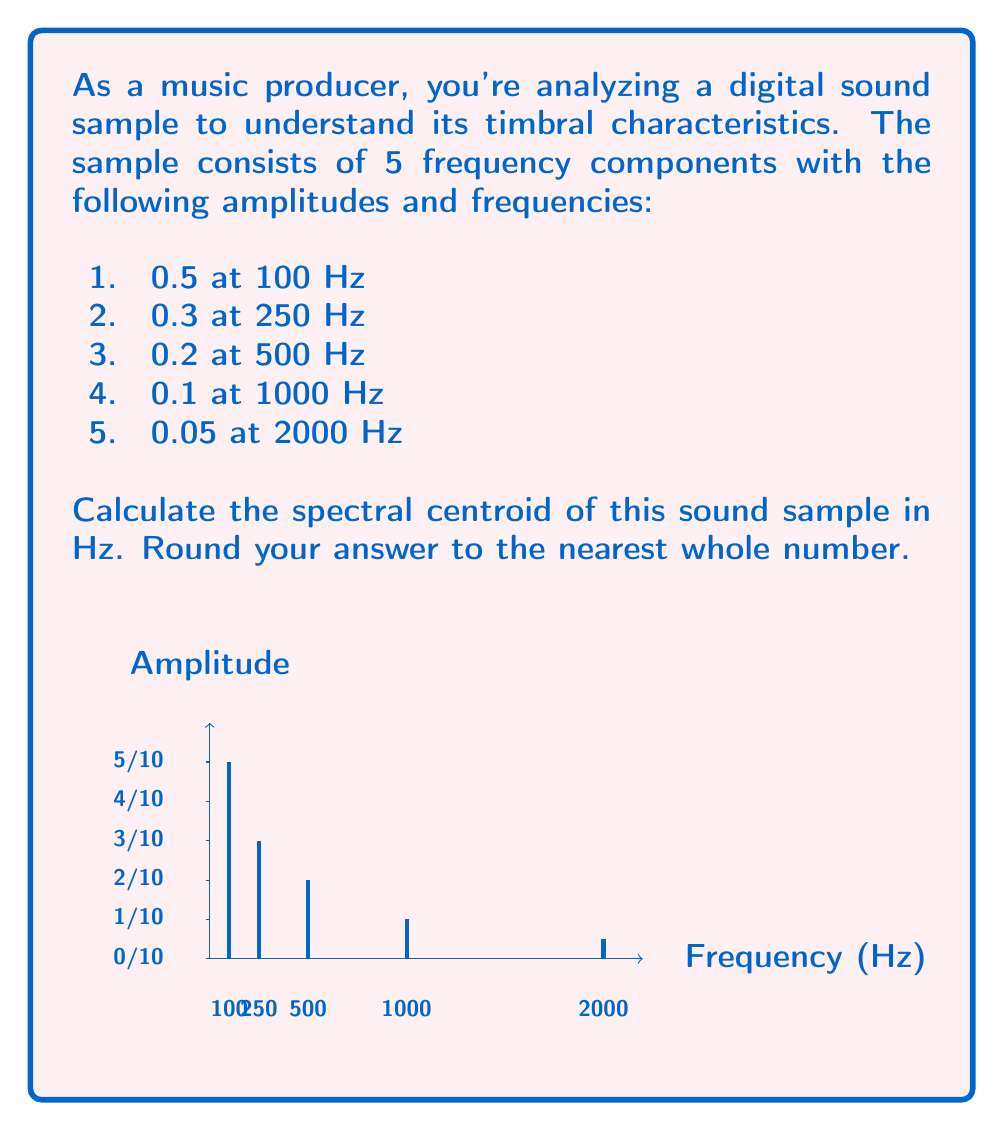Help me with this question. To calculate the spectral centroid, we need to follow these steps:

1) The spectral centroid is given by the formula:

   $$ C = \frac{\sum_{n=1}^{N} f_n A_n}{\sum_{n=1}^{N} A_n} $$

   where $f_n$ is the frequency of each component and $A_n$ is its amplitude.

2) Let's calculate the numerator:
   
   $$(100 \cdot 0.5) + (250 \cdot 0.3) + (500 \cdot 0.2) + (1000 \cdot 0.1) + (2000 \cdot 0.05)$$
   $$= 50 + 75 + 100 + 100 + 100 = 425$$

3) Now, let's calculate the denominator:
   
   $$0.5 + 0.3 + 0.2 + 0.1 + 0.05 = 1.15$$

4) Dividing the numerator by the denominator:

   $$ C = \frac{425}{1.15} \approx 369.57 $$

5) Rounding to the nearest whole number:

   $$369.57 \approx 370$$

Therefore, the spectral centroid of this sound sample is approximately 370 Hz.
Answer: 370 Hz 